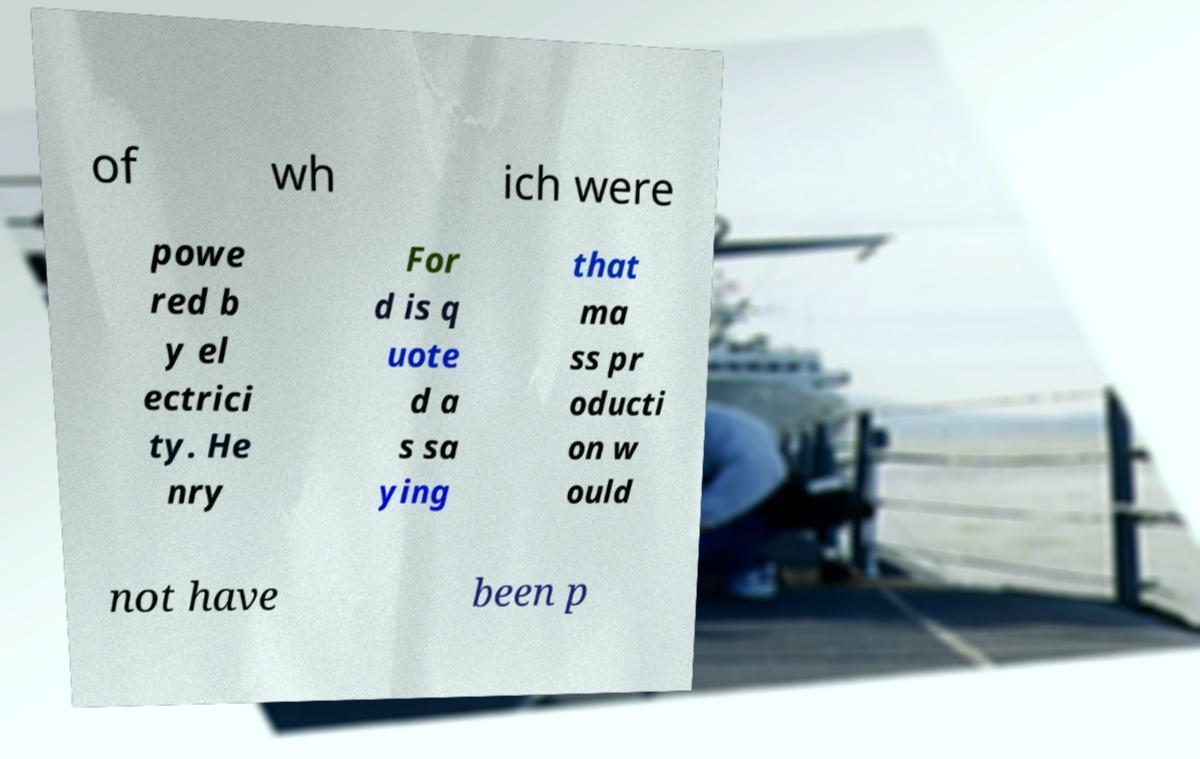What messages or text are displayed in this image? I need them in a readable, typed format. of wh ich were powe red b y el ectrici ty. He nry For d is q uote d a s sa ying that ma ss pr oducti on w ould not have been p 